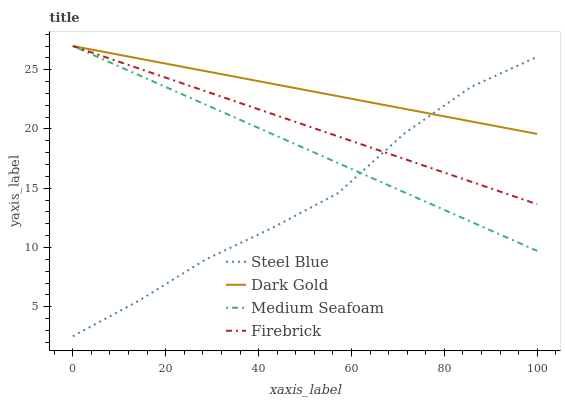Does Steel Blue have the minimum area under the curve?
Answer yes or no. Yes. Does Dark Gold have the maximum area under the curve?
Answer yes or no. Yes. Does Medium Seafoam have the minimum area under the curve?
Answer yes or no. No. Does Medium Seafoam have the maximum area under the curve?
Answer yes or no. No. Is Medium Seafoam the smoothest?
Answer yes or no. Yes. Is Steel Blue the roughest?
Answer yes or no. Yes. Is Steel Blue the smoothest?
Answer yes or no. No. Is Medium Seafoam the roughest?
Answer yes or no. No. Does Steel Blue have the lowest value?
Answer yes or no. Yes. Does Medium Seafoam have the lowest value?
Answer yes or no. No. Does Dark Gold have the highest value?
Answer yes or no. Yes. Does Steel Blue have the highest value?
Answer yes or no. No. Does Dark Gold intersect Medium Seafoam?
Answer yes or no. Yes. Is Dark Gold less than Medium Seafoam?
Answer yes or no. No. Is Dark Gold greater than Medium Seafoam?
Answer yes or no. No. 